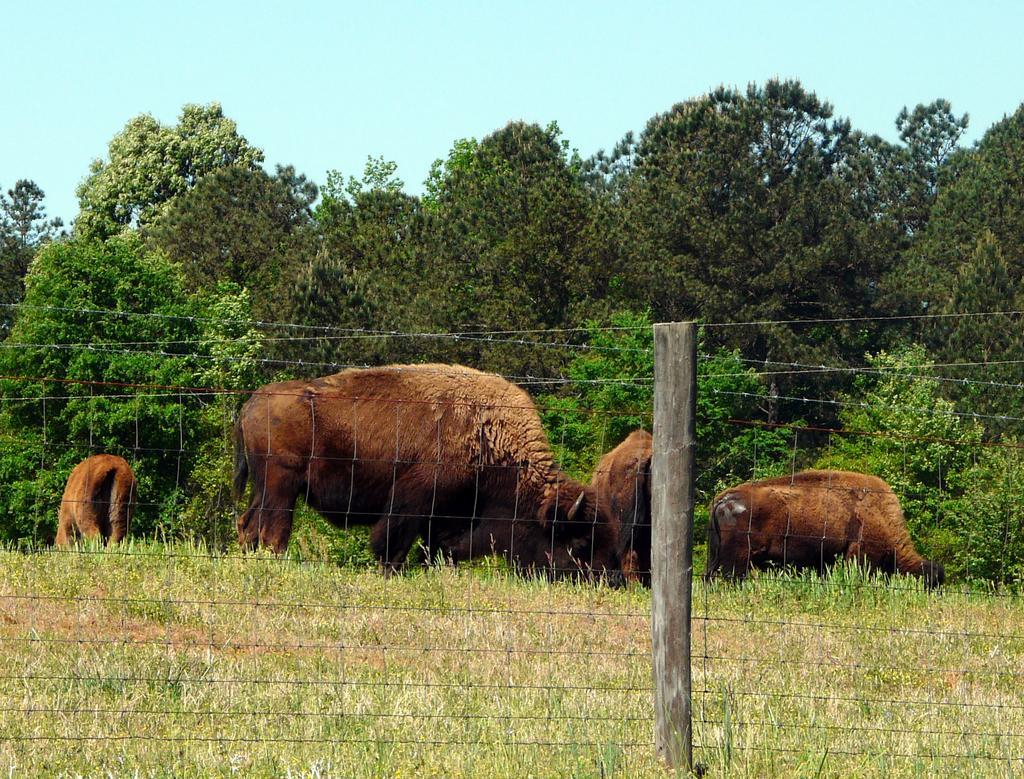How would you summarize this image in a sentence or two? In the center of the image, we can see animals and there is a fence. In the background, there are trees. At the top, there is sky. 